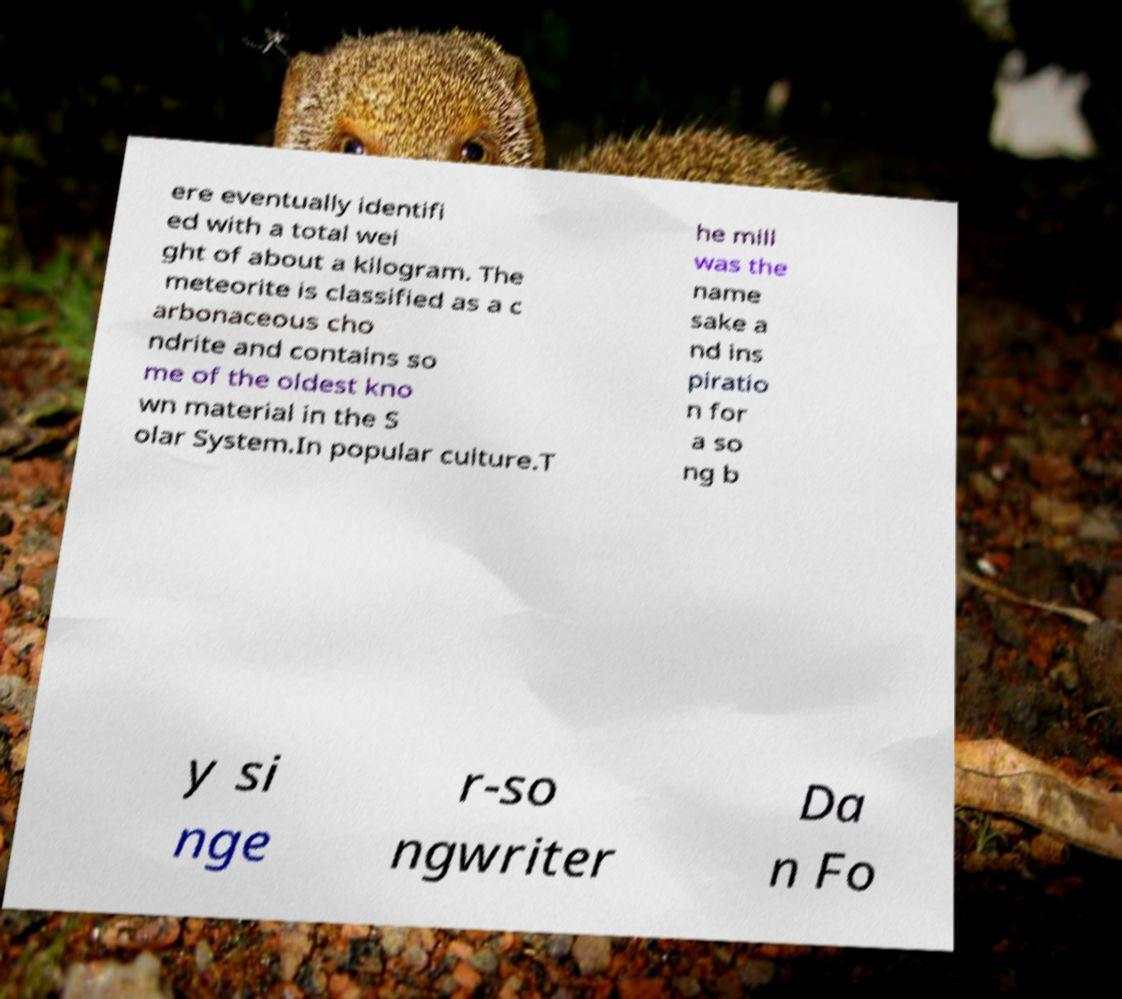Could you assist in decoding the text presented in this image and type it out clearly? ere eventually identifi ed with a total wei ght of about a kilogram. The meteorite is classified as a c arbonaceous cho ndrite and contains so me of the oldest kno wn material in the S olar System.In popular culture.T he mill was the name sake a nd ins piratio n for a so ng b y si nge r-so ngwriter Da n Fo 